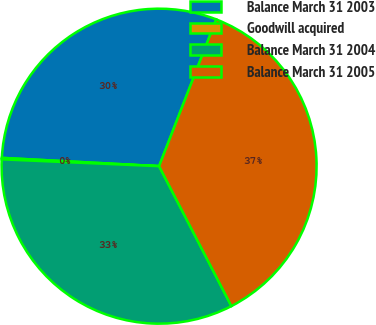Convert chart. <chart><loc_0><loc_0><loc_500><loc_500><pie_chart><fcel>Balance March 31 2003<fcel>Goodwill acquired<fcel>Balance March 31 2004<fcel>Balance March 31 2005<nl><fcel>30.06%<fcel>0.15%<fcel>33.28%<fcel>36.5%<nl></chart> 